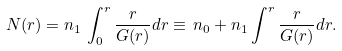Convert formula to latex. <formula><loc_0><loc_0><loc_500><loc_500>N ( r ) = n _ { 1 } \, \int _ { 0 } ^ { r } { \frac { r } { G ( r ) } d r } \equiv \, n _ { 0 } + n _ { 1 } \int ^ { r } { \frac { r } { G ( r ) } d r } .</formula> 